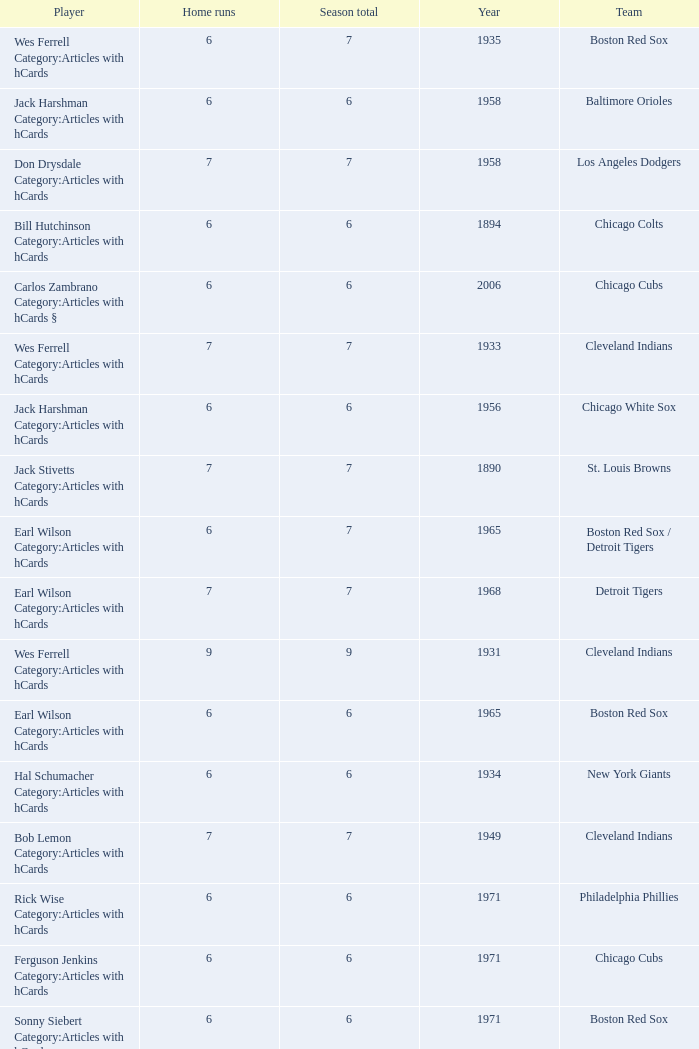Tell me the highest home runs for cleveland indians years before 1931 None. 